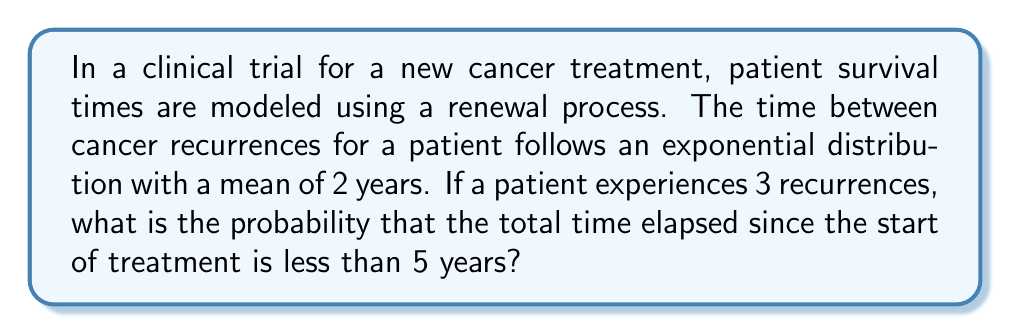Teach me how to tackle this problem. Let's approach this step-by-step:

1) First, we need to recognize that the sum of n independent exponentially distributed random variables follows a Gamma distribution. In this case, we're looking at the sum of 3 exponential distributions.

2) The parameters for the Gamma distribution are:
   - Shape parameter (k): number of exponential distributions summed = 3
   - Scale parameter (θ): mean of each exponential distribution = 2

3) The cumulative distribution function (CDF) of a Gamma distribution is given by:

   $$F(x; k, θ) = \frac{γ(k, x/θ)}{Γ(k)}$$

   where γ(k, x/θ) is the lower incomplete gamma function and Γ(k) is the gamma function.

4) In our case:
   k = 3
   θ = 2
   x = 5 (we want probability of time < 5 years)

5) Plugging these into the CDF:

   $$P(X < 5) = F(5; 3, 2) = \frac{γ(3, 5/2)}{Γ(3)}$$

6) This can be calculated using statistical software or mathematical tables. The result is approximately 0.7769.

7) Therefore, the probability that the total time elapsed since the start of treatment is less than 5 years, given 3 recurrences, is about 0.7769 or 77.69%.
Answer: 0.7769 